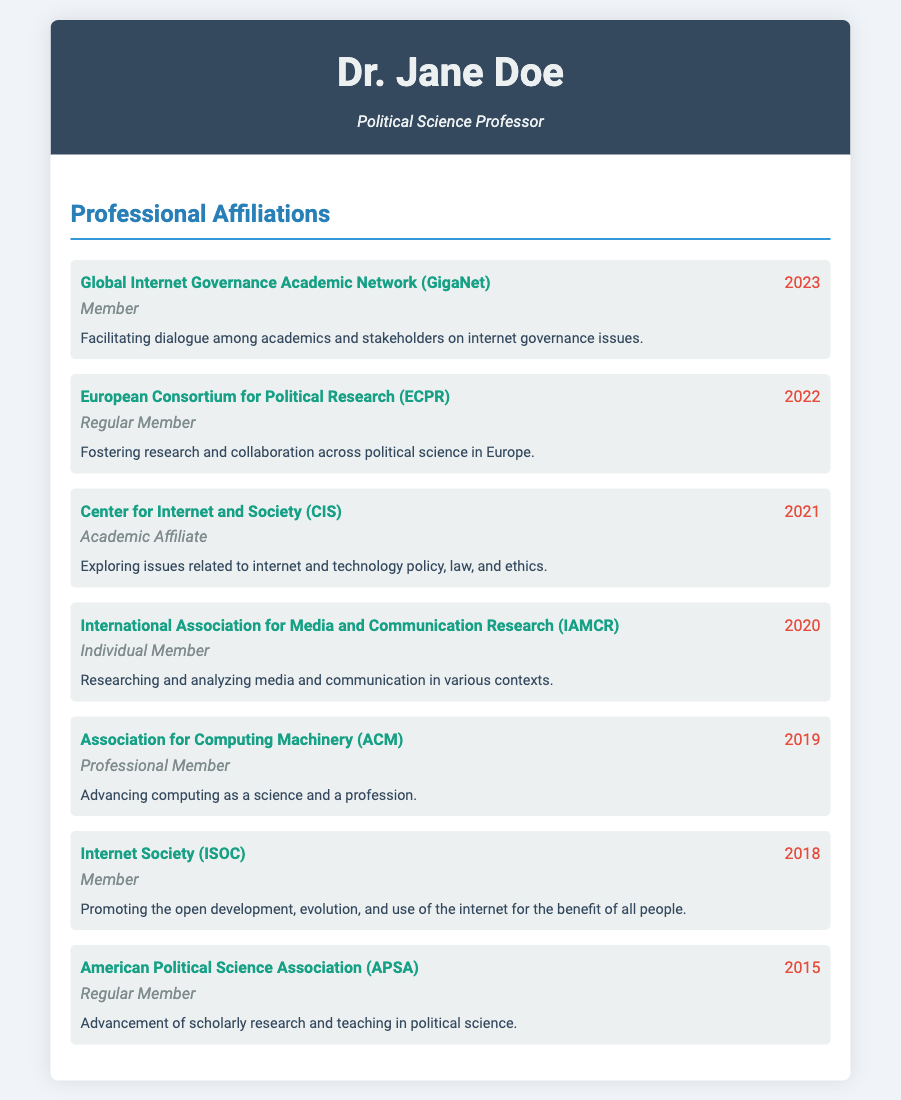What is the highest year of membership listed? The highest year of membership indicates the most recent affiliation with an organization, which is 2023 for the Global Internet Governance Academic Network (GigaNet).
Answer: 2023 What organization did Dr. Jane Doe join in 2021? The organization joined in 2021 is the Center for Internet and Society (CIS).
Answer: Center for Internet and Society (CIS) What type of membership does Dr. Jane Doe hold in the European Consortium for Political Research? The type of membership mentioned for the European Consortium for Political Research is Regular Member, which reflects her active status in this organization.
Answer: Regular Member Which organization focuses on internet governance issues? The Global Internet Governance Academic Network (GigaNet) is specifically mentioned for facilitating dialogue on internet governance issues.
Answer: Global Internet Governance Academic Network (GigaNet) How many years has Dr. Jane Doe been a member of the Internet Society? The Internet Society was joined in 2018 and the current year is 2023, indicating that she has been a member for 5 years.
Answer: 5 years What is the primary focus of the Association for Computing Machinery? The primary focus of the Association for Computing Machinery is to advance computing as a science and a profession.
Answer: Advancing computing as a science and a profession Which organization aims to promote the open development of the internet? The organization that promotes the open development, evolution, and use of the internet is the Internet Society (ISOC).
Answer: Internet Society (ISOC) How many affiliations were joined before 2020? The memberships joined before 2020 include those from the American Political Science Association (2015), the Internet Society (2018), and the Association for Computing Machinery (2019), totaling 3 affiliations.
Answer: 3 affiliations 